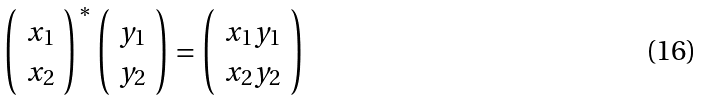<formula> <loc_0><loc_0><loc_500><loc_500>\left ( \begin{array} { c } x _ { 1 } \\ x _ { 2 } \end{array} \right ) ^ { * } \left ( \begin{array} { c } y _ { 1 } \\ y _ { 2 } \end{array} \right ) = \left ( \begin{array} { c } x _ { 1 } y _ { 1 } \\ x _ { 2 } y _ { 2 } \end{array} \right )</formula> 